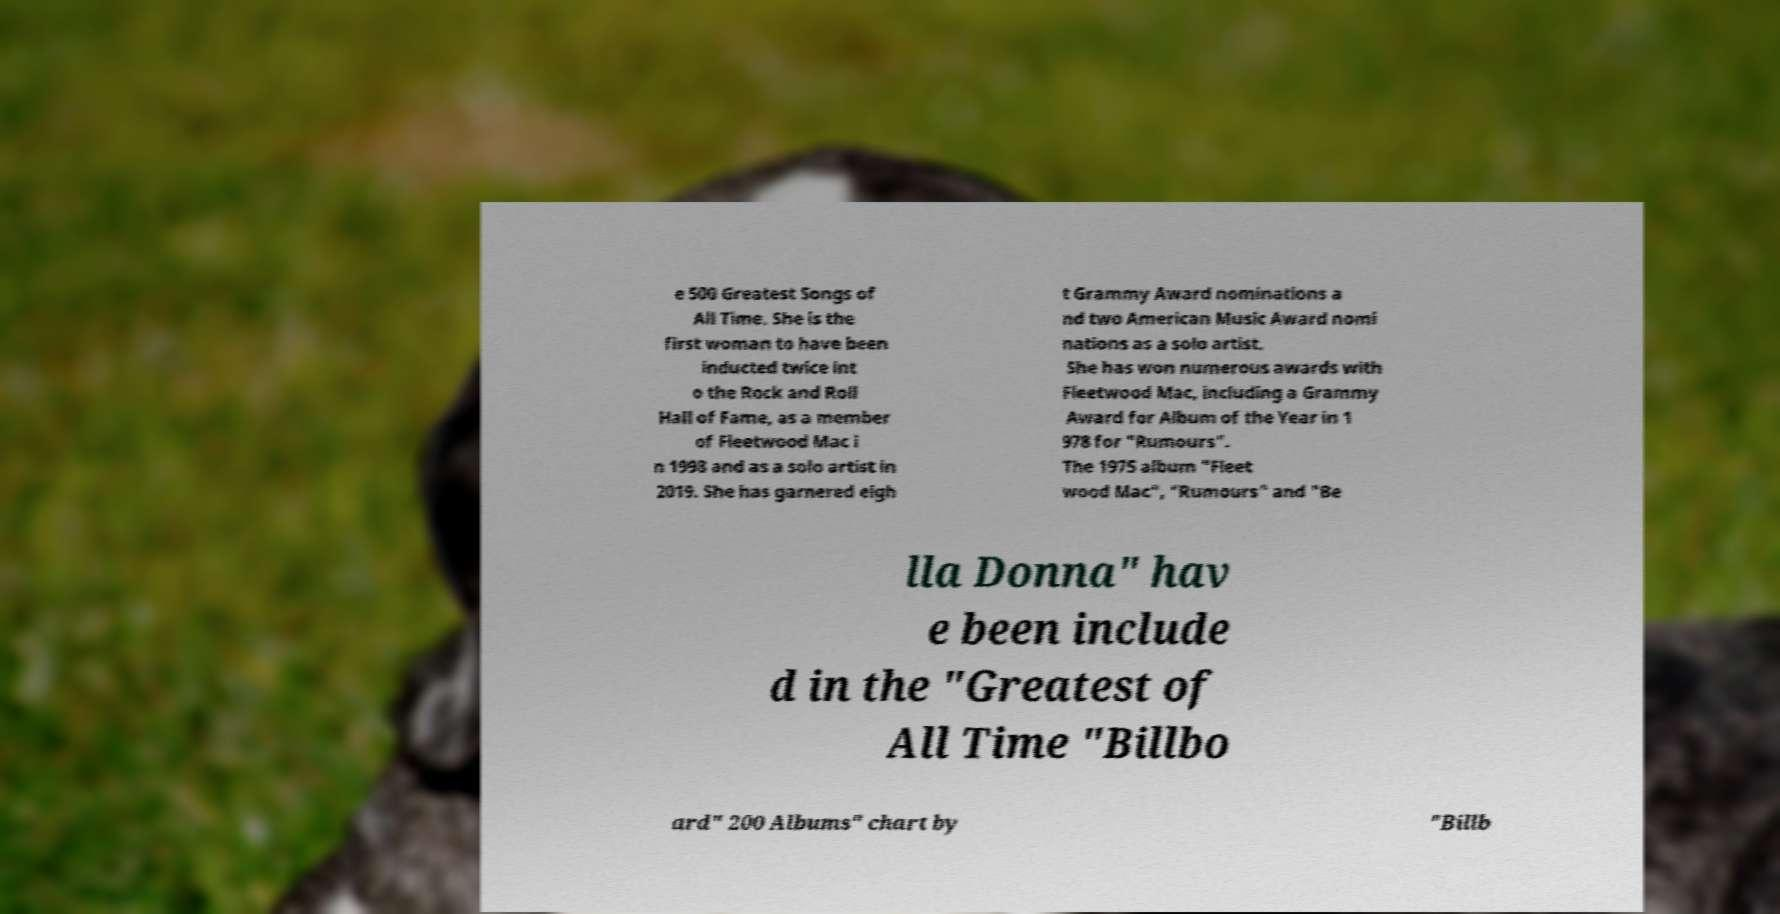Can you read and provide the text displayed in the image?This photo seems to have some interesting text. Can you extract and type it out for me? e 500 Greatest Songs of All Time. She is the first woman to have been inducted twice int o the Rock and Roll Hall of Fame, as a member of Fleetwood Mac i n 1998 and as a solo artist in 2019. She has garnered eigh t Grammy Award nominations a nd two American Music Award nomi nations as a solo artist. She has won numerous awards with Fleetwood Mac, including a Grammy Award for Album of the Year in 1 978 for "Rumours". The 1975 album "Fleet wood Mac", "Rumours" and "Be lla Donna" hav e been include d in the "Greatest of All Time "Billbo ard" 200 Albums" chart by "Billb 